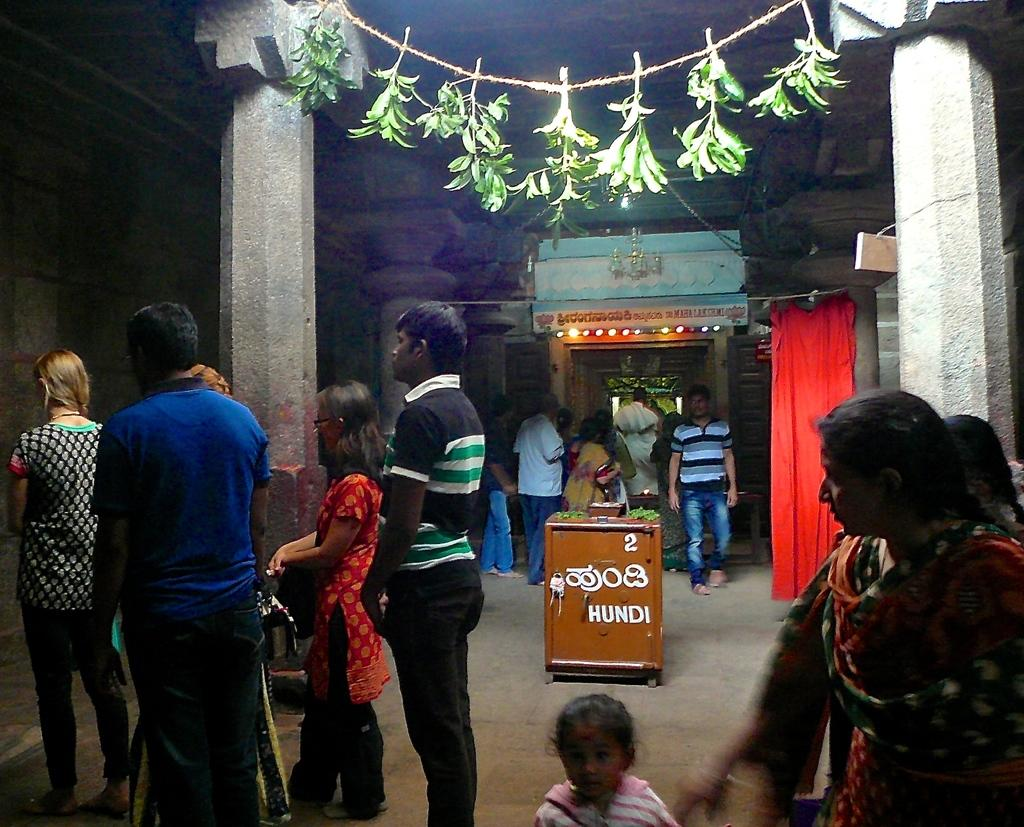What type of location is shown in the image? The image depicts the inside of a temple. Are there any people present in the image? Yes, there are people standing on the left side of the image, and a woman is standing on the right side of the image. What type of boats can be seen in the image? There are no boats present in the image; it depicts the inside of a temple. Is the queen present in the image? There is no mention of a queen in the image, as it only shows people inside a temple. 